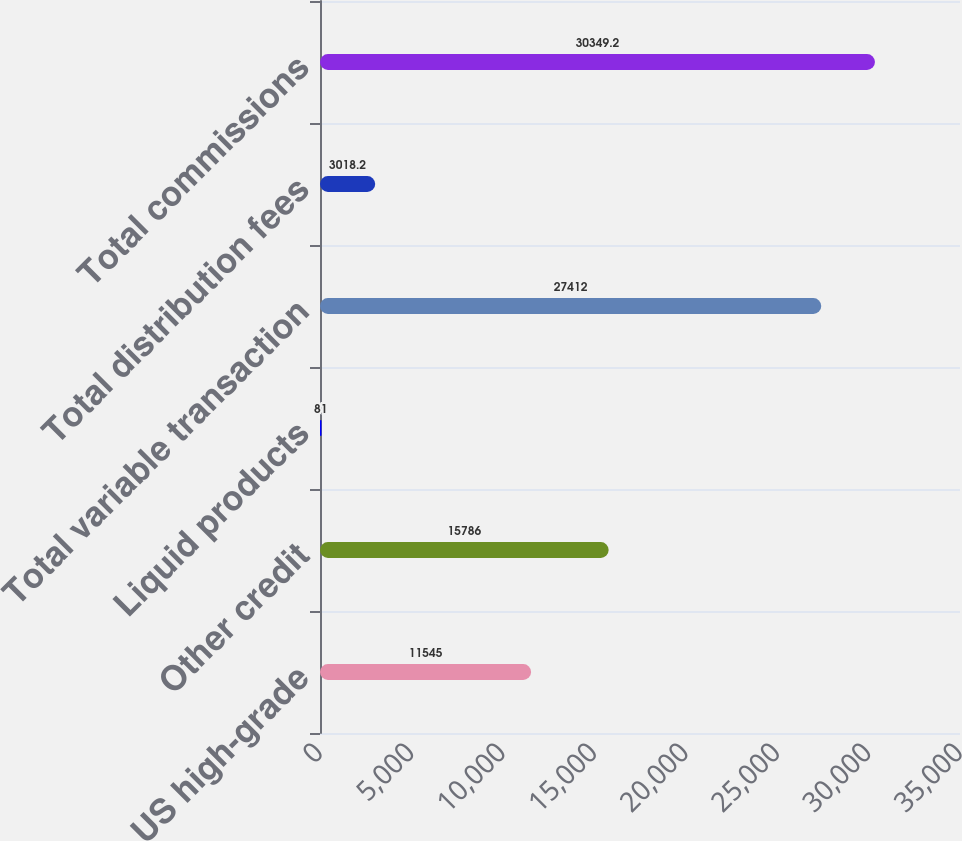<chart> <loc_0><loc_0><loc_500><loc_500><bar_chart><fcel>US high-grade<fcel>Other credit<fcel>Liquid products<fcel>Total variable transaction<fcel>Total distribution fees<fcel>Total commissions<nl><fcel>11545<fcel>15786<fcel>81<fcel>27412<fcel>3018.2<fcel>30349.2<nl></chart> 